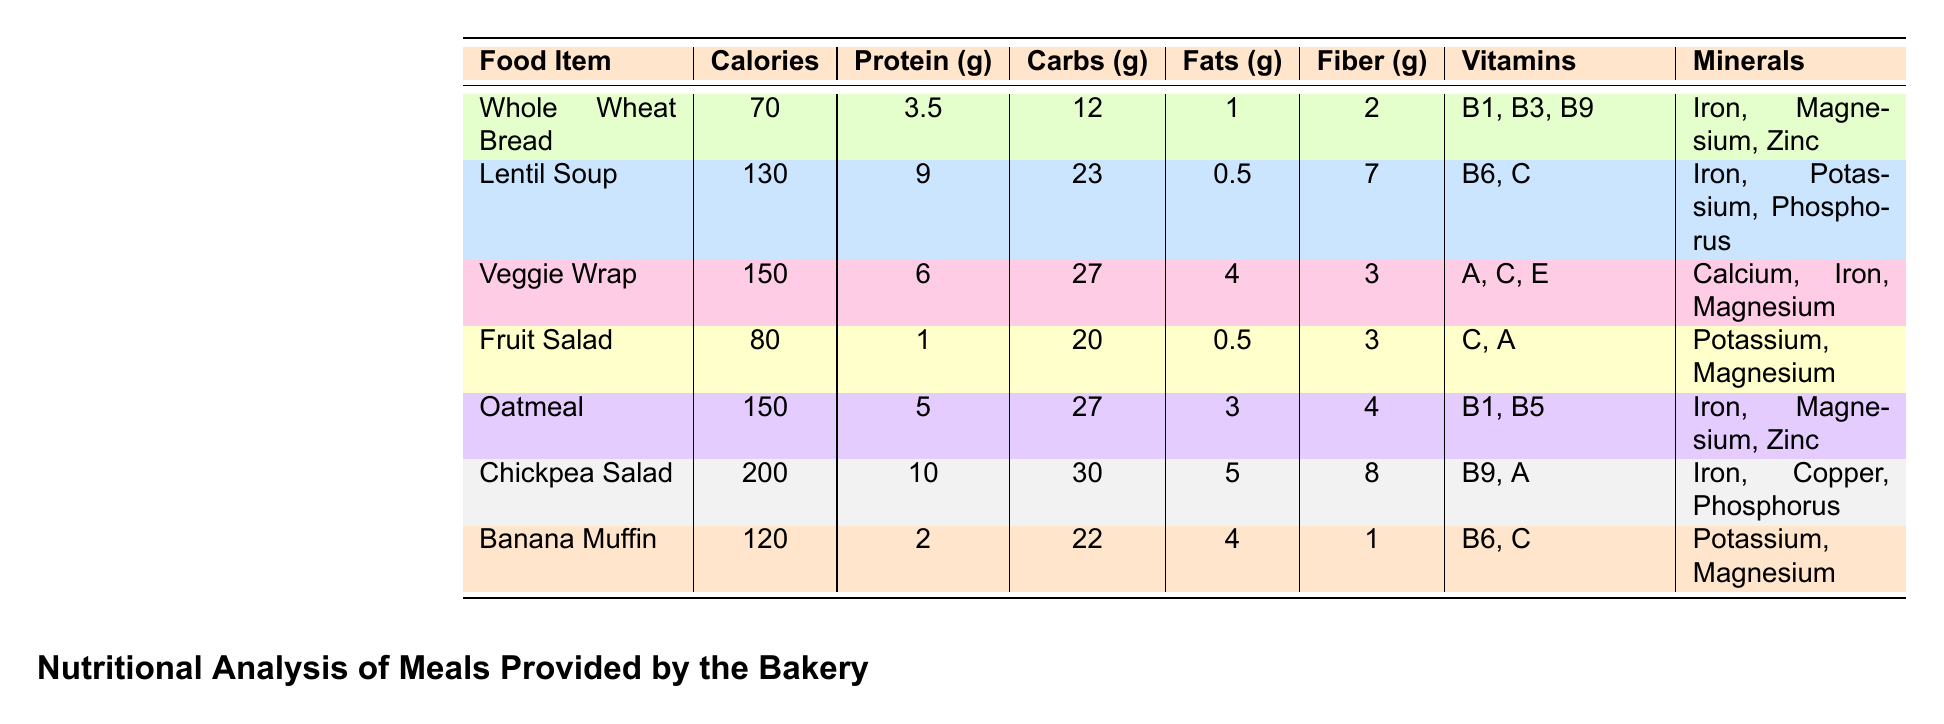What food item has the highest protein content? From the table, the food item with the highest protein content is the Chickpea Salad, which has 10 grams of protein.
Answer: Chickpea Salad What is the total calorie count of the Veggie Wrap and the Chickpea Salad combined? The Veggie Wrap has 150 calories and the Chickpea Salad has 200 calories. Adding these together gives 150 + 200 = 350 calories.
Answer: 350 Does the Fruit Salad contain Vitamin C? Looking at the vitamins listed for the Fruit Salad, it includes Vitamin C (Ascorbic Acid).
Answer: Yes Which food item contains the most fiber? The Chickpea Salad has the highest fiber content at 8 grams, compared to the other food items listed.
Answer: Chickpea Salad What is the average carbohydrate content of all listed food items? The carbohydrate contents are: Whole Wheat Bread (12), Lentil Soup (23), Veggie Wrap (27), Fruit Salad (20), Oatmeal (27), Chickpea Salad (30), and Banana Muffin (22). The total is 12 + 23 + 27 + 20 + 27 + 30 + 22 =  161, and there are 7 items, so the average is 161 / 7 ≈ 23. We'll round it to 23.
Answer: 23 Does Oatmeal contain Vitamin B1? The vitamins for Oatmeal include B1 (Thiamine), indicating that it does contain this vitamin.
Answer: Yes Which food item contains the least calories? From the data, Whole Wheat Bread has the least calories at 70, making it the food item with the lowest calorie count.
Answer: Whole Wheat Bread What is the total amount of fats in the Banana Muffin and the Fruit Salad? The Banana Muffin has 4 grams of fat and the Fruit Salad has 0.5 grams. Adding these amounts gives 4 + 0.5 = 4.5 grams of fat.
Answer: 4.5 Are there any food items that provide Iron as a mineral? Yes, the following food items provide Iron: Whole Wheat Bread, Lentil Soup, Veggie Wrap, Oatmeal, Chickpea Salad, and Banana Muffin, confirming that multiple items contain Iron.
Answer: Yes 